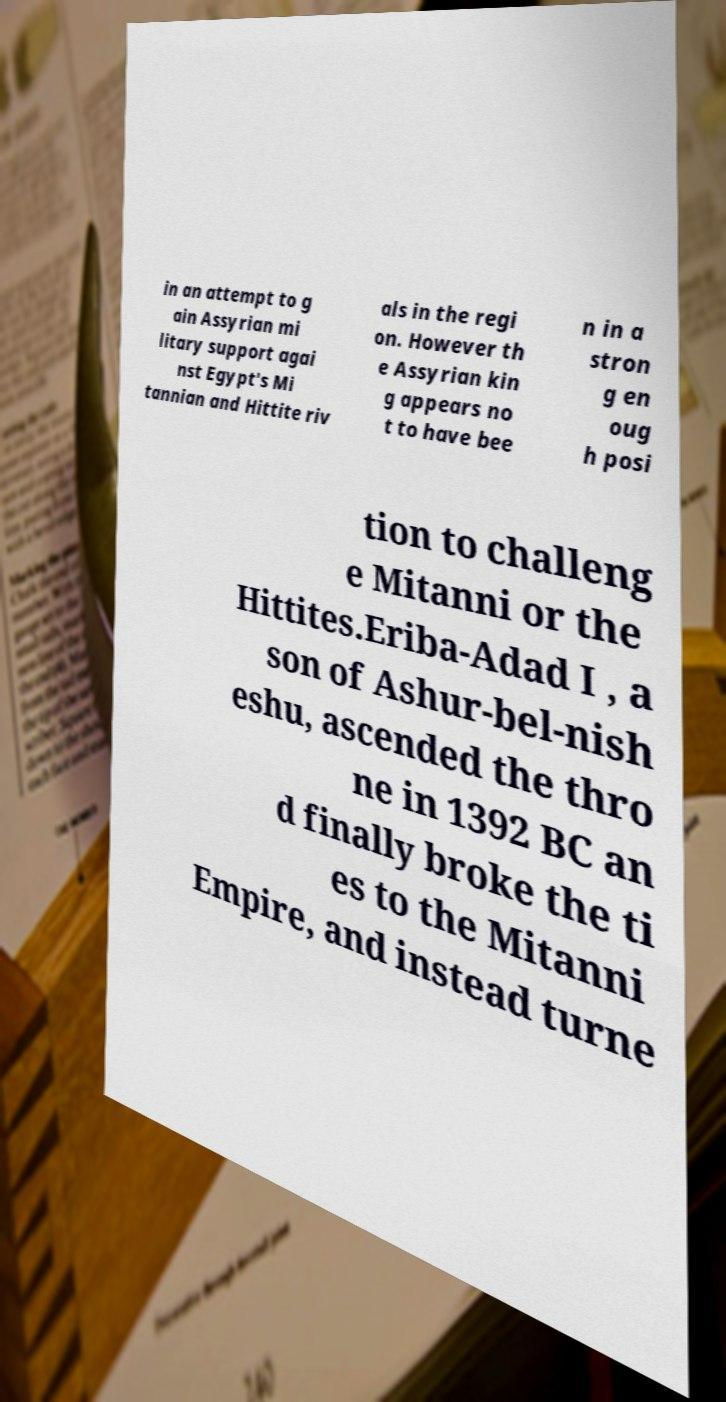I need the written content from this picture converted into text. Can you do that? in an attempt to g ain Assyrian mi litary support agai nst Egypt's Mi tannian and Hittite riv als in the regi on. However th e Assyrian kin g appears no t to have bee n in a stron g en oug h posi tion to challeng e Mitanni or the Hittites.Eriba-Adad I , a son of Ashur-bel-nish eshu, ascended the thro ne in 1392 BC an d finally broke the ti es to the Mitanni Empire, and instead turne 